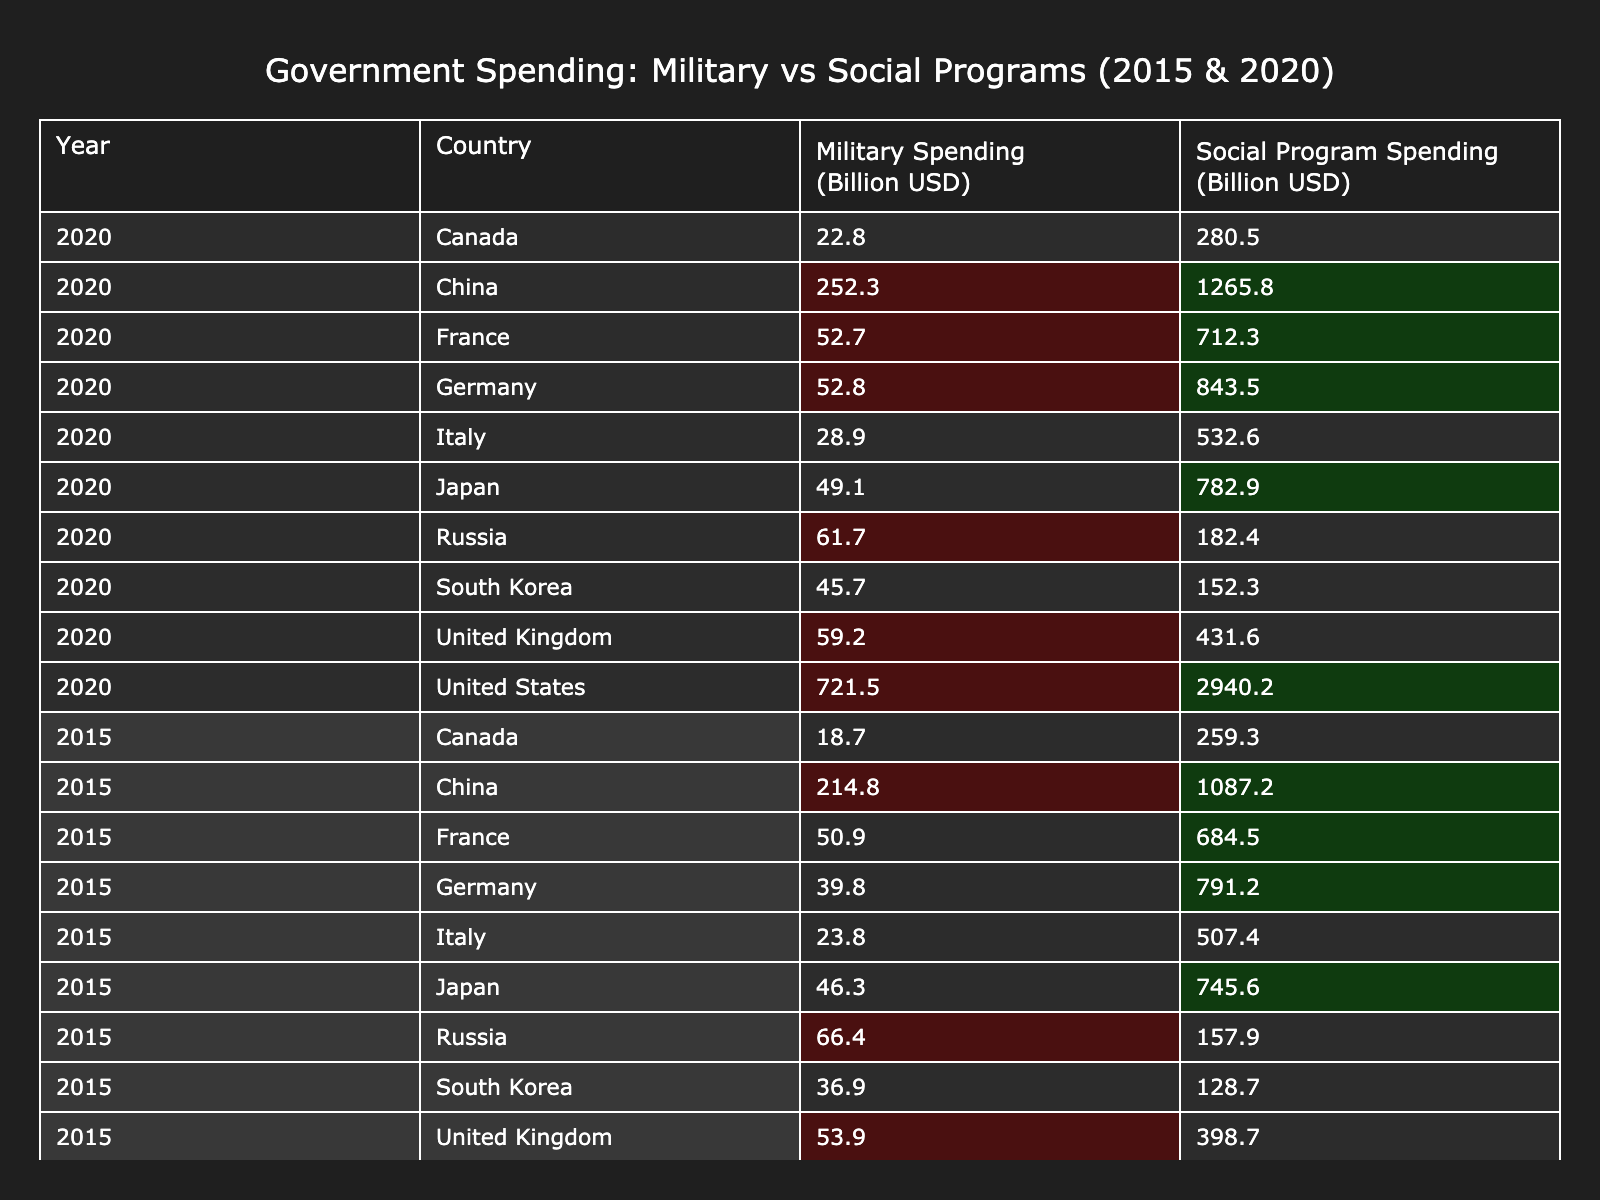What was the military spending of the United States in 2020? The table shows that the military spending of the United States in 2020 is listed as 721.5 billion USD.
Answer: 721.5 billion USD Which country had the highest social program spending in 2020? By comparing the social program spending across all countries in 2020, we see that the United States has the highest amount at 2940.2 billion USD.
Answer: United States What is the difference in military spending between China and Russia in 2020? From the table, China spent 252.3 billion USD while Russia spent 61.7 billion USD. The difference is calculated as 252.3 - 61.7 = 190.6 billion USD.
Answer: 190.6 billion USD Is the military spending of Germany higher or lower than its social program spending in 2020? The table indicates Germany's military spending at 52.8 billion USD and social program spending at 843.5 billion USD, clearly showing that military spending is lower.
Answer: Lower What was the total military spending of the top three countries (United States, China, and Russia) in 2020? Adding the military spending amounts for these three countries gives 721.5 (US) + 252.3 (China) + 61.7 (Russia) = 1035.5 billion USD.
Answer: 1035.5 billion USD How much more did the United States spend on social programs compared to military spending in 2020? The United States spent 2940.2 billion USD on social programs and 721.5 billion USD on military. The difference is calculated as 2940.2 - 721.5 = 2218.7 billion USD.
Answer: 2218.7 billion USD What percentage of the total spending (military + social) does Japan allocate to military spending in 2020? Japan's military spending is 49.1 billion USD, and its social program spending is 782.9 billion USD. The total is 49.1 + 782.9 = 832 billion USD. The percentage is (49.1 / 832) * 100 ≈ 5.9%.
Answer: Approximately 5.9% Which country spent more on military programs in 2015, Canada or Italy? In 2015, Canada spent 18.7 billion USD and Italy spent 23.8 billion USD on military programs. Comparing these amounts shows that Italy spent more on military programs.
Answer: Italy Did social program spending increase for any country from 2015 to 2020? By comparing the social program spending amounts, we find all countries' social program spending in 2020 is higher than in 2015, indicating an increase.
Answer: Yes What is the average military spending among the countries listed for 2020? The military spending values for 2020 (721.5, 252.3, 61.7, 59.2, 52.7, 52.8, 49.1, 45.7, 28.9, 22.8) sum up to 1,210.2 billion USD, and there are 10 countries, making the average 1210.2 / 10 = 121.02 billion USD.
Answer: 121.02 billion USD 